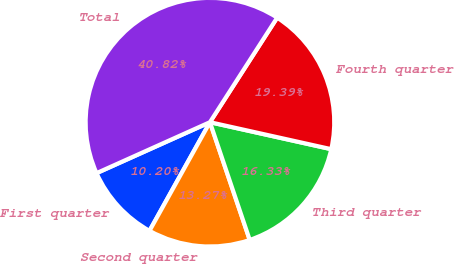<chart> <loc_0><loc_0><loc_500><loc_500><pie_chart><fcel>First quarter<fcel>Second quarter<fcel>Third quarter<fcel>Fourth quarter<fcel>Total<nl><fcel>10.2%<fcel>13.27%<fcel>16.33%<fcel>19.39%<fcel>40.82%<nl></chart> 